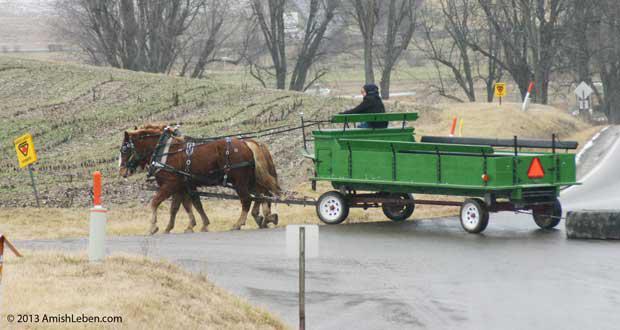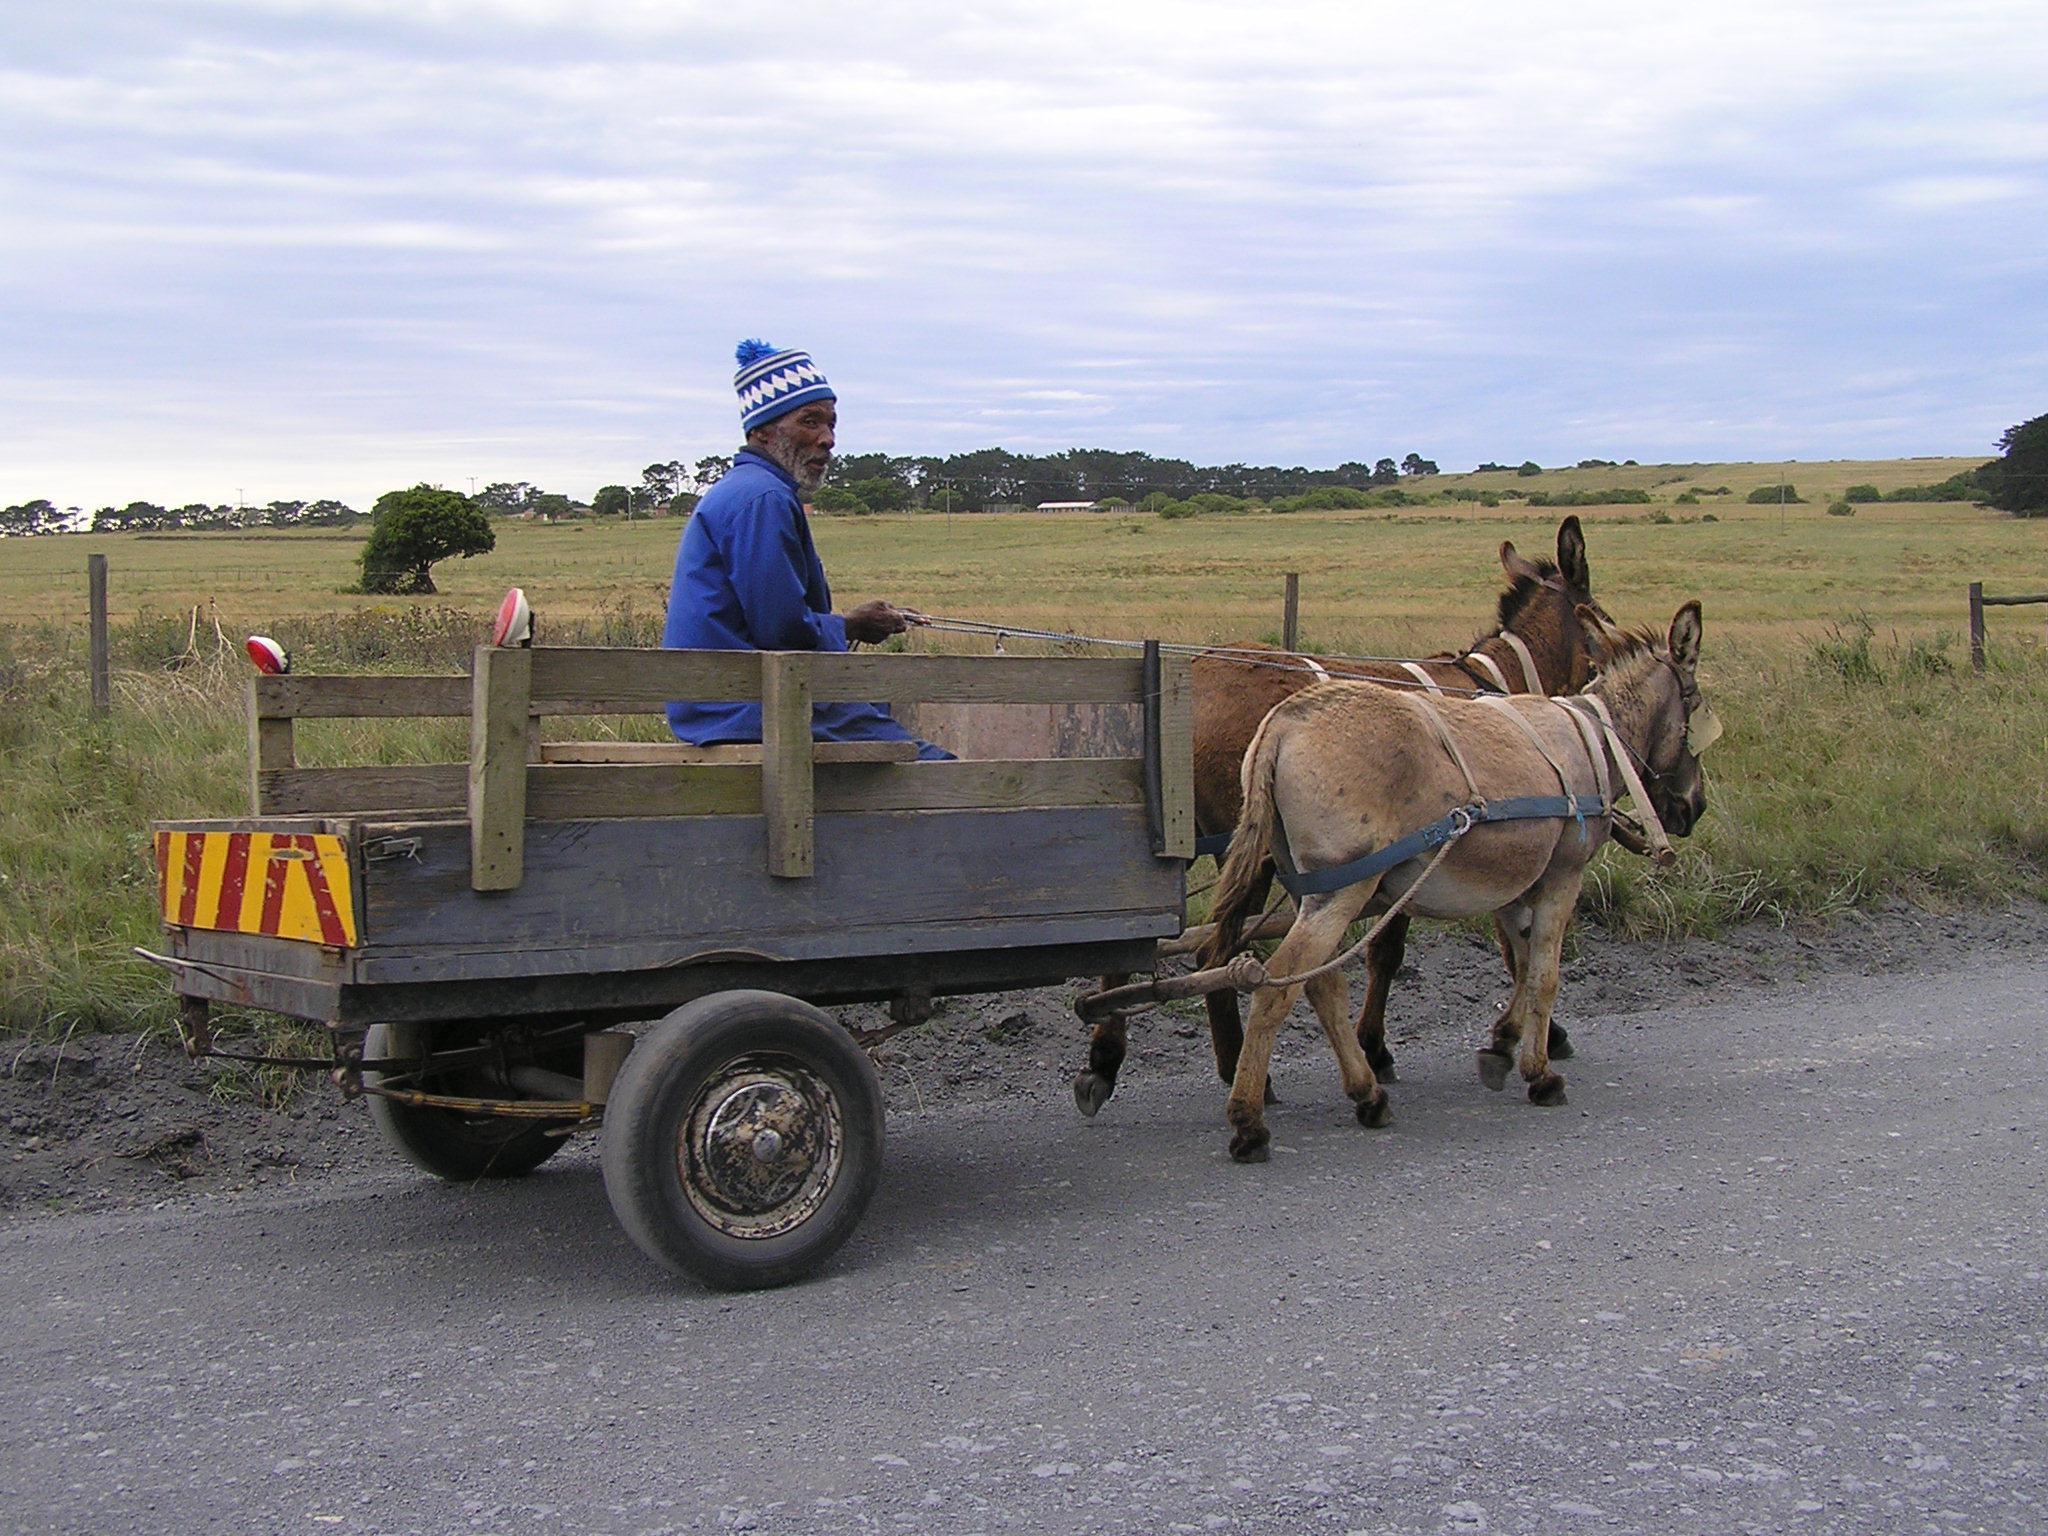The first image is the image on the left, the second image is the image on the right. Analyze the images presented: Is the assertion "There are no less than three animals pulling something on wheels." valid? Answer yes or no. Yes. The first image is the image on the left, the second image is the image on the right. Evaluate the accuracy of this statement regarding the images: "the right side pics has a four wheel wagon moving to the right". Is it true? Answer yes or no. No. 